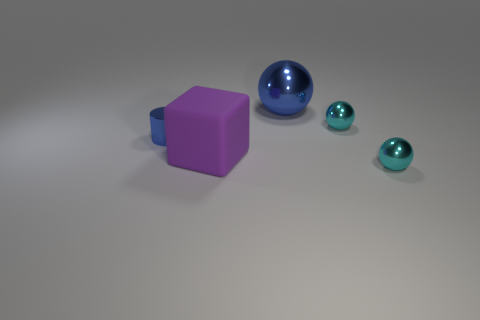There is a ball that is the same color as the metal cylinder; what is it made of?
Your response must be concise. Metal. What number of other objects are there of the same color as the big ball?
Provide a short and direct response. 1. There is a cyan object in front of the big purple matte block; what is its size?
Provide a succinct answer. Small. There is a large shiny thing that is behind the tiny blue cylinder; is it the same color as the small cylinder?
Provide a short and direct response. Yes. What number of blue objects are the same shape as the purple object?
Offer a terse response. 0. What number of things are either metallic spheres in front of the blue cylinder or things that are in front of the blue metallic ball?
Your answer should be very brief. 4. How many purple things are either big rubber blocks or cylinders?
Offer a terse response. 1. There is a small thing that is to the right of the rubber block and behind the purple matte block; what is it made of?
Offer a very short reply. Metal. Is the material of the small blue cylinder the same as the large purple cube?
Your response must be concise. No. What number of blue shiny objects have the same size as the blue sphere?
Your answer should be compact. 0. 